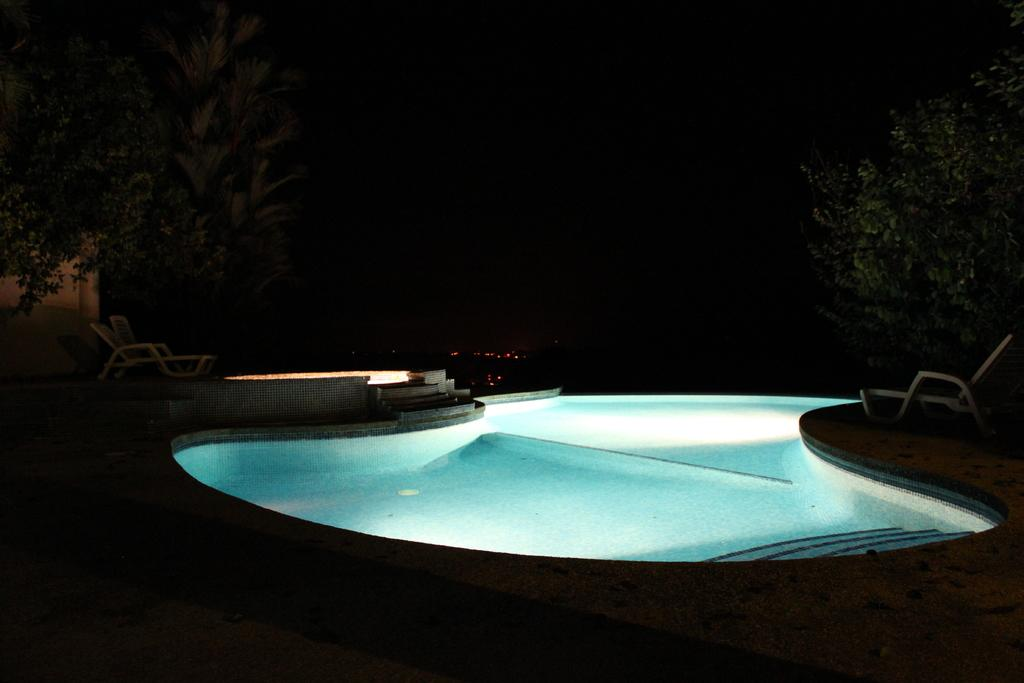What is the main feature in the center of the image? There is a swimming pool with lights in the center of the image. What can be seen in the background of the image? There are trees visible in the image. What type of furniture is present in the image? Relaxing chairs are present in the image. Can you describe any architectural elements in the image? There is a staircase in the image. Are there any other objects or features in the image? Yes, there are a few other objects in the image. What type of tub is visible in the image? There is no tub present in the image. What ingredients are used to make the stew in the image? There is no stew present in the image. 